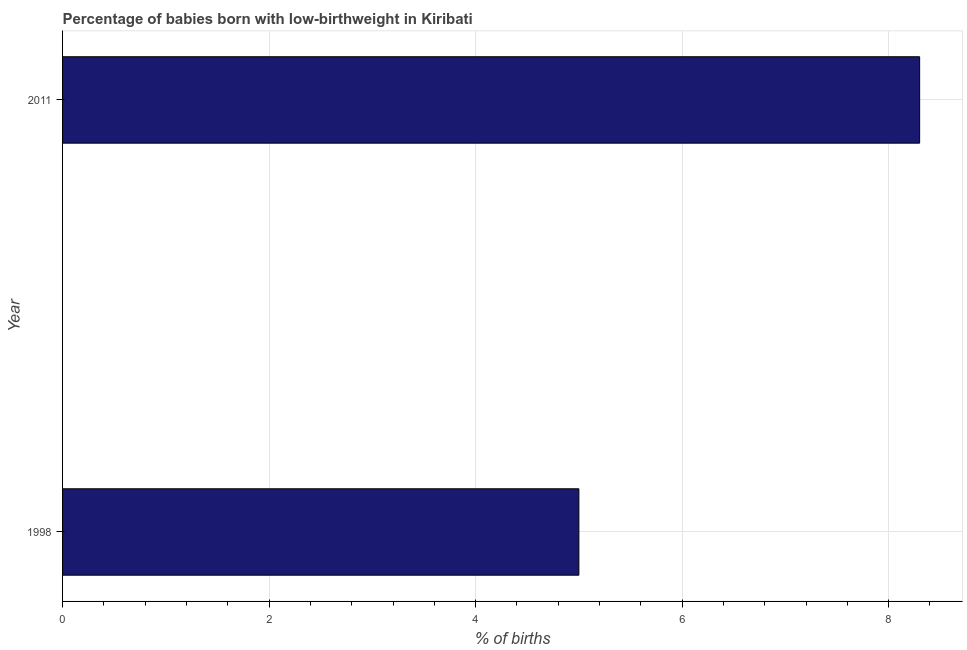Does the graph contain any zero values?
Your response must be concise. No. Does the graph contain grids?
Your answer should be very brief. Yes. What is the title of the graph?
Provide a succinct answer. Percentage of babies born with low-birthweight in Kiribati. What is the label or title of the X-axis?
Keep it short and to the point. % of births. What is the percentage of babies who were born with low-birthweight in 1998?
Provide a short and direct response. 5. In which year was the percentage of babies who were born with low-birthweight minimum?
Provide a short and direct response. 1998. What is the sum of the percentage of babies who were born with low-birthweight?
Make the answer very short. 13.3. What is the average percentage of babies who were born with low-birthweight per year?
Keep it short and to the point. 6.65. What is the median percentage of babies who were born with low-birthweight?
Provide a succinct answer. 6.65. What is the ratio of the percentage of babies who were born with low-birthweight in 1998 to that in 2011?
Make the answer very short. 0.6. What is the difference between two consecutive major ticks on the X-axis?
Your response must be concise. 2. Are the values on the major ticks of X-axis written in scientific E-notation?
Provide a succinct answer. No. What is the ratio of the % of births in 1998 to that in 2011?
Give a very brief answer. 0.6. 